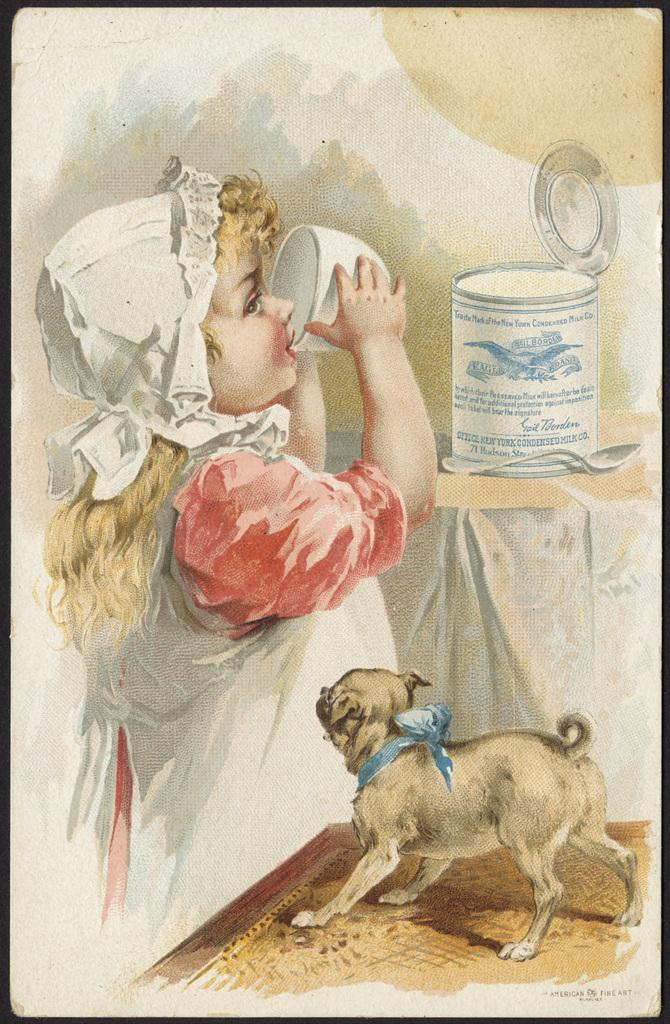What is depicted in the drawing in the image? The image contains a drawing of a girl, and the drawing includes a dog, a spoon, a table, a tin, and a cup. Can you describe the setting of the drawing? The drawing features a table with various objects, including a tin and a cup. What is written at the bottom right corner of the paper? Something is written at the bottom right corner of the paper, but the specific text is not visible in the image. How does the crook interact with the steam in the drawing? There is no crook or steam present in the drawing; it features a girl, a dog, a spoon, a table, a tin, and a cup. 